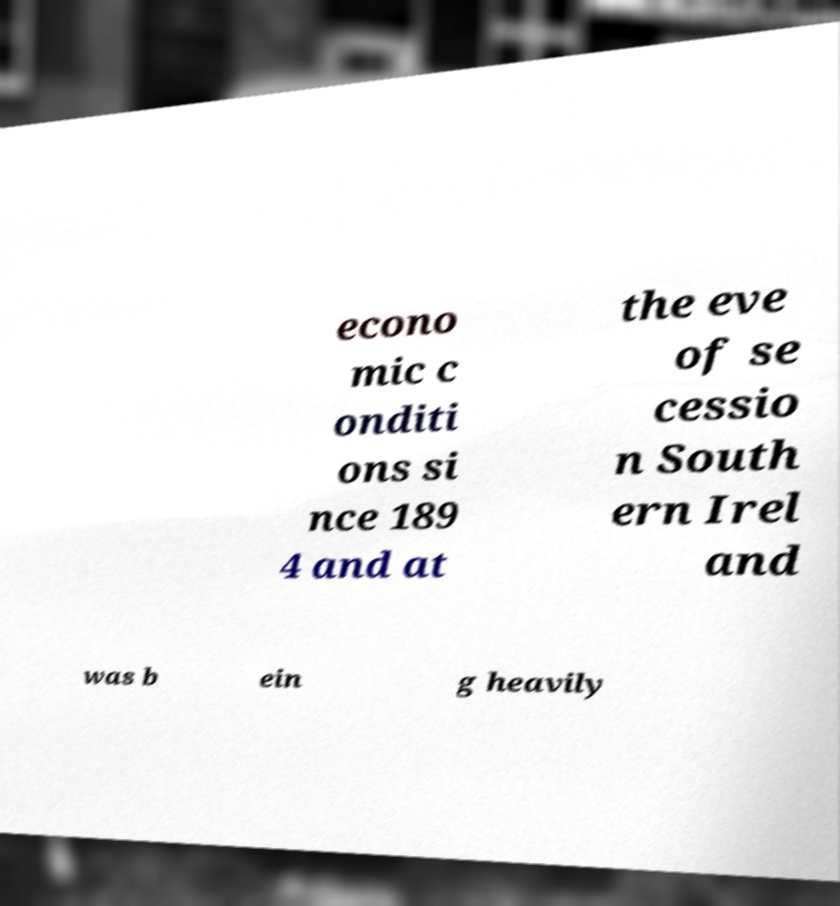There's text embedded in this image that I need extracted. Can you transcribe it verbatim? econo mic c onditi ons si nce 189 4 and at the eve of se cessio n South ern Irel and was b ein g heavily 